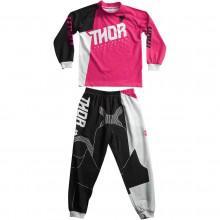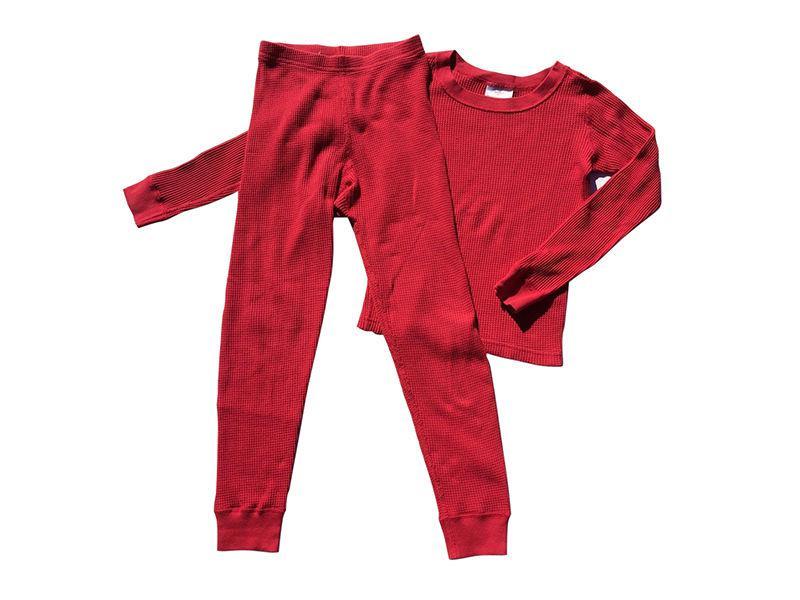The first image is the image on the left, the second image is the image on the right. Examine the images to the left and right. Is the description "One or more outfits are """"Thing 1 and Thing 2"""" themed." accurate? Answer yes or no. No. 